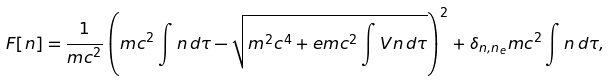Convert formula to latex. <formula><loc_0><loc_0><loc_500><loc_500>F [ n ] = { \frac { 1 } { m c ^ { 2 } } } \left ( m c ^ { 2 } \int n \, d \tau - { \sqrt { m ^ { 2 } c ^ { 4 } + e m c ^ { 2 } \int V n \, d \tau } } \right ) ^ { 2 } + \delta _ { n , n _ { e } } m c ^ { 2 } \int n \, d \tau ,</formula> 